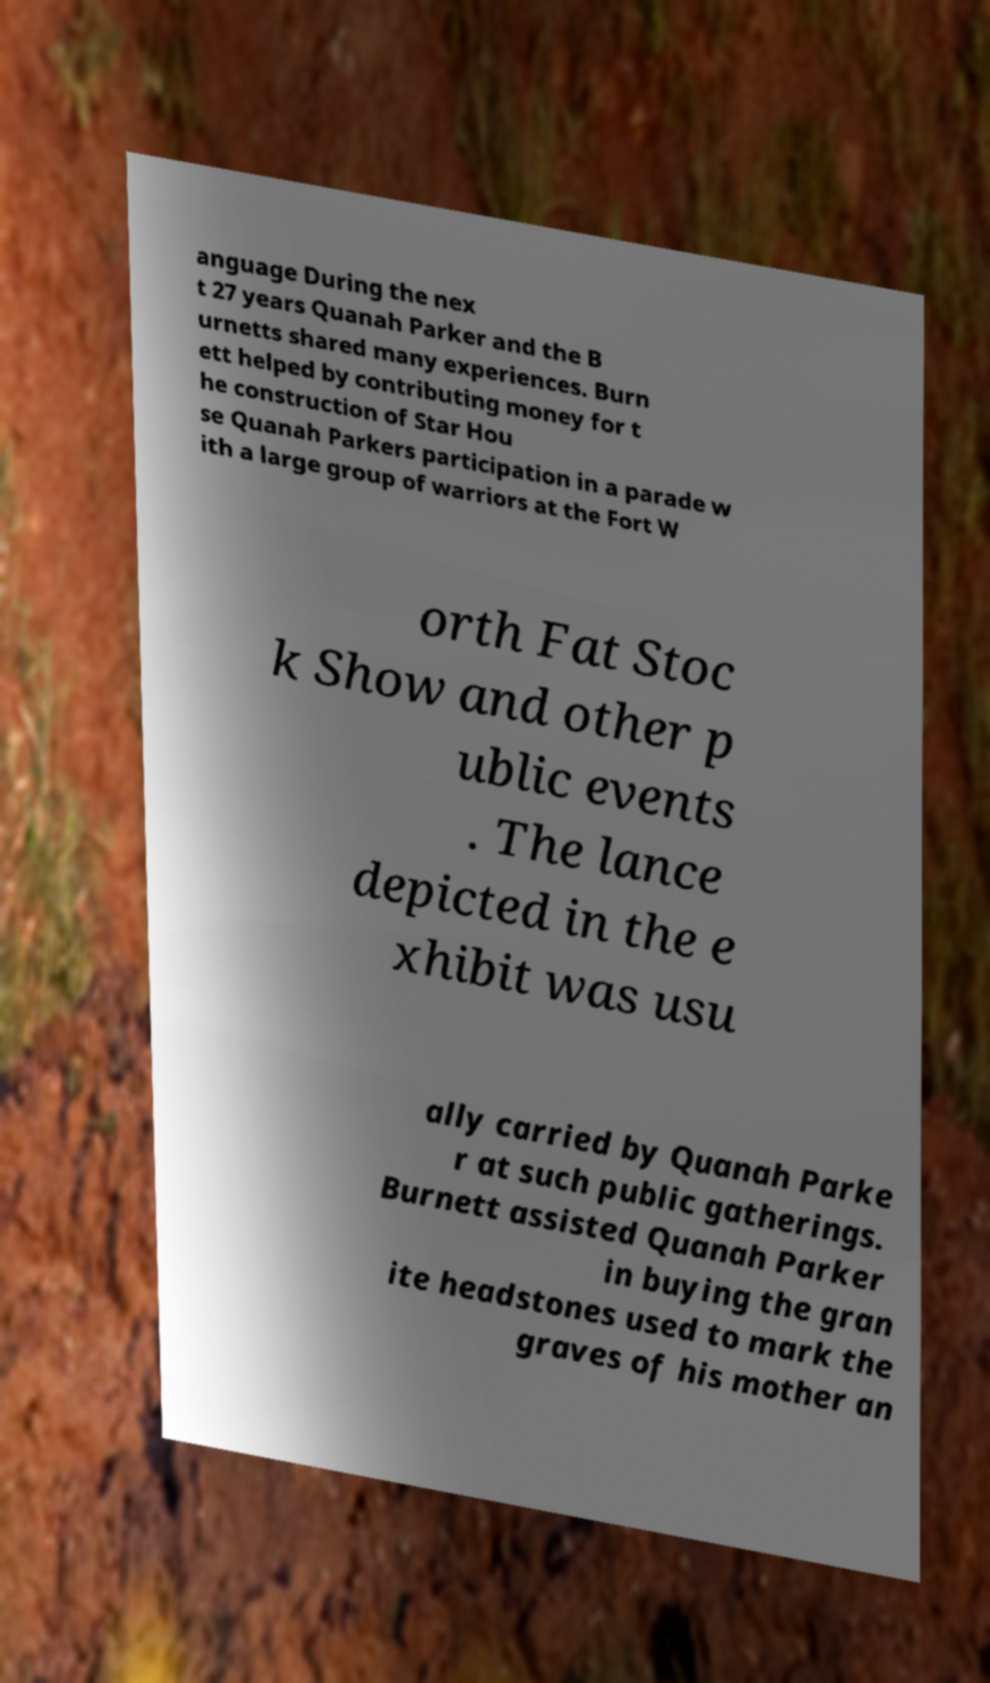For documentation purposes, I need the text within this image transcribed. Could you provide that? anguage During the nex t 27 years Quanah Parker and the B urnetts shared many experiences. Burn ett helped by contributing money for t he construction of Star Hou se Quanah Parkers participation in a parade w ith a large group of warriors at the Fort W orth Fat Stoc k Show and other p ublic events . The lance depicted in the e xhibit was usu ally carried by Quanah Parke r at such public gatherings. Burnett assisted Quanah Parker in buying the gran ite headstones used to mark the graves of his mother an 